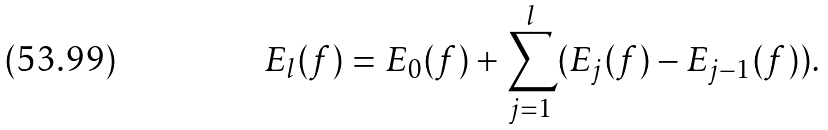<formula> <loc_0><loc_0><loc_500><loc_500>E _ { l } ( f ) = E _ { 0 } ( f ) + \sum _ { j = 1 } ^ { l } ( E _ { j } ( f ) - E _ { j - 1 } ( f ) ) .</formula> 